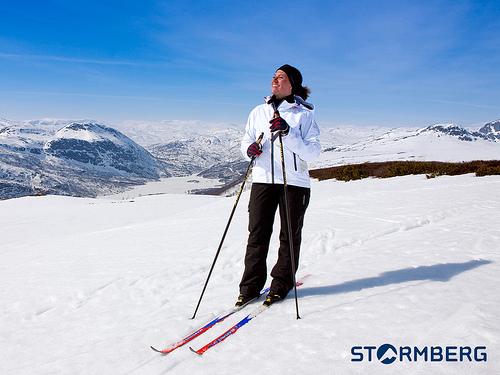Does the woman appear happy?
Answer briefly. Yes. Is the woman in a valley?
Be succinct. No. What color are the skis?
Be succinct. Red and blue. 